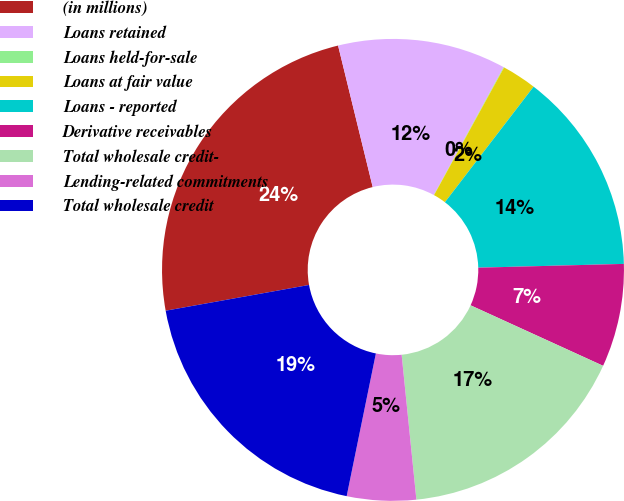Convert chart to OTSL. <chart><loc_0><loc_0><loc_500><loc_500><pie_chart><fcel>(in millions)<fcel>Loans retained<fcel>Loans held-for-sale<fcel>Loans at fair value<fcel>Loans - reported<fcel>Derivative receivables<fcel>Total wholesale credit-<fcel>Lending-related commitments<fcel>Total wholesale credit<nl><fcel>24.01%<fcel>11.77%<fcel>0.04%<fcel>2.43%<fcel>14.17%<fcel>7.23%<fcel>16.57%<fcel>4.83%<fcel>18.96%<nl></chart> 